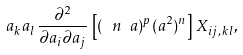Convert formula to latex. <formula><loc_0><loc_0><loc_500><loc_500>a _ { k } a _ { l } \, \frac { \partial ^ { 2 } } { \partial a _ { i } \partial a _ { j } } \, \left [ ( \ n \ a ) ^ { p } ( a ^ { 2 } ) ^ { n } \right ] \, X _ { i j , \, k l } ,</formula> 